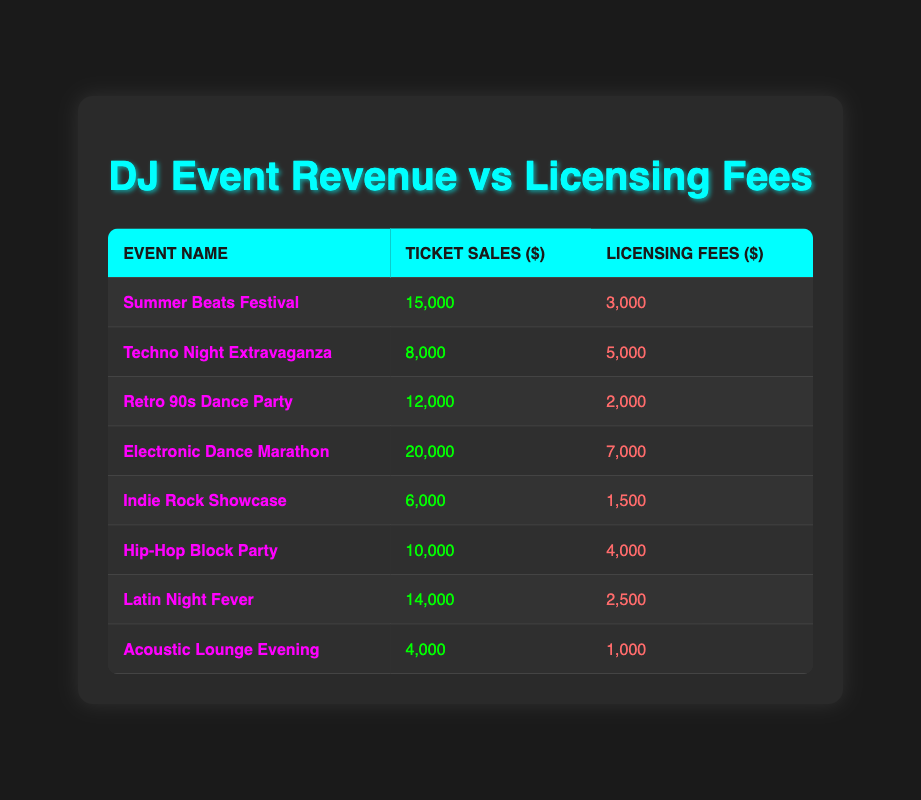What is the total revenue from ticket sales across all events? To find the total revenue from ticket sales, we need to sum the ticket sales of each event: 15000 + 8000 + 12000 + 20000 + 6000 + 10000 + 14000 + 4000 = 80000.
Answer: 80000 Which event had the highest licensing fees? By checking the licensing fees of each event, we find that the Electronic Dance Marathon had the highest fees at 7000 dollars.
Answer: Electronic Dance Marathon What is the average ticket sales amount for all events? The total ticket sales from the previous calculation is 80000, and there are 8 events. We calculate the average by dividing the total sales by the number of events: 80000 / 8 = 10000.
Answer: 10000 Is the licensing fee for the Techno Night Extravaganza higher than that of the Indie Rock Showcase? The licensing fee for Techno Night Extravaganza is 5000, while for Indie Rock Showcase, it is 1500. Therefore, 5000 is greater than 1500, making the statement true.
Answer: Yes Which event had the largest difference between ticket sales and licensing fees? First, we calculate the difference for each event: Summer Beats Festival: 15000 - 3000 = 12000, Techno Night Extravaganza: 8000 - 5000 = 3000, Retro 90s Dance Party: 12000 - 2000 = 10000, Electronic Dance Marathon: 20000 - 7000 = 13000, Indie Rock Showcase: 6000 - 1500 = 4500, Hip-Hop Block Party: 10000 - 4000 = 6000, Latin Night Fever: 14000 - 2500 = 11500, Acoustic Lounge Evening: 4000 - 1000 = 3000. The largest difference is 13000 for the Electronic Dance Marathon.
Answer: Electronic Dance Marathon Which event has the lowest ticket sales among all events? By reviewing the ticket sales, we see that the Acoustic Lounge Evening has the lowest ticket sales at 4000 dollars.
Answer: Acoustic Lounge Evening 